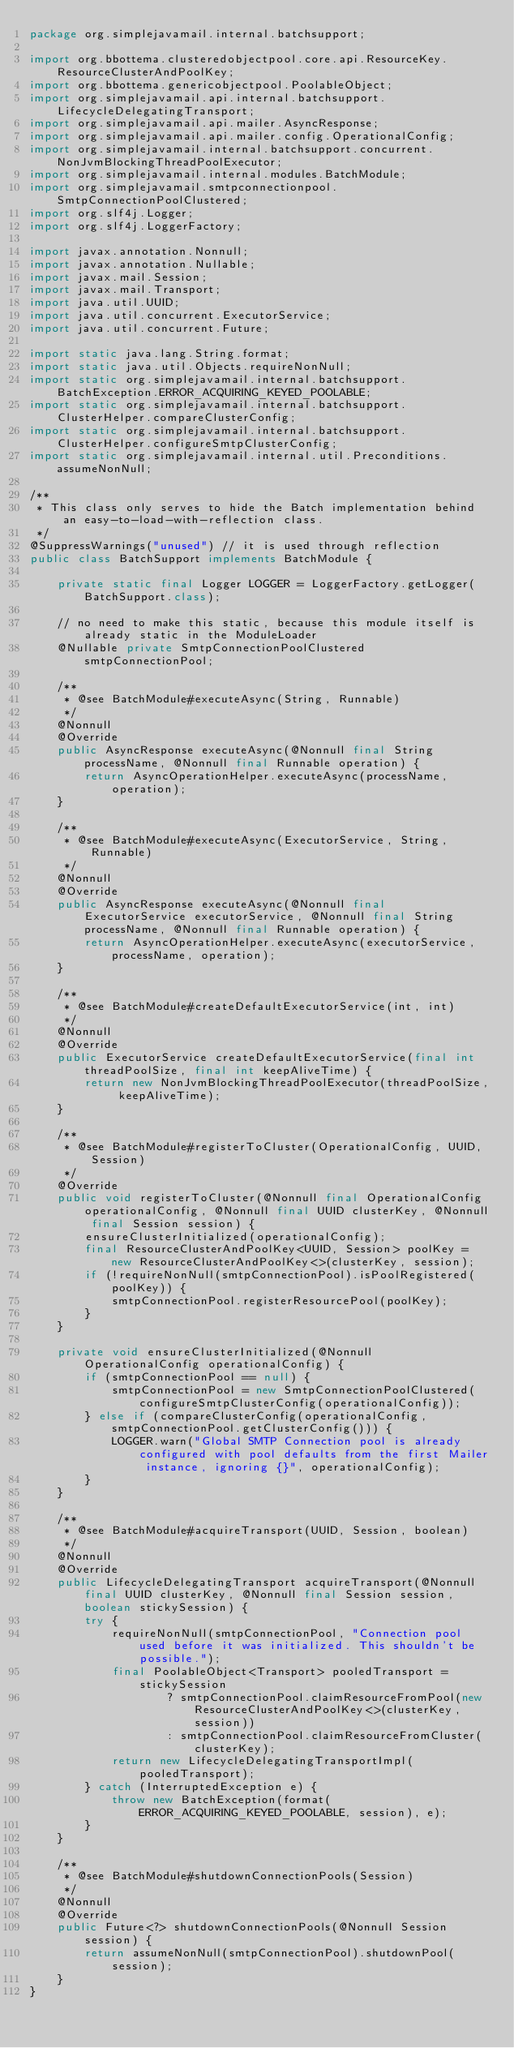<code> <loc_0><loc_0><loc_500><loc_500><_Java_>package org.simplejavamail.internal.batchsupport;

import org.bbottema.clusteredobjectpool.core.api.ResourceKey.ResourceClusterAndPoolKey;
import org.bbottema.genericobjectpool.PoolableObject;
import org.simplejavamail.api.internal.batchsupport.LifecycleDelegatingTransport;
import org.simplejavamail.api.mailer.AsyncResponse;
import org.simplejavamail.api.mailer.config.OperationalConfig;
import org.simplejavamail.internal.batchsupport.concurrent.NonJvmBlockingThreadPoolExecutor;
import org.simplejavamail.internal.modules.BatchModule;
import org.simplejavamail.smtpconnectionpool.SmtpConnectionPoolClustered;
import org.slf4j.Logger;
import org.slf4j.LoggerFactory;

import javax.annotation.Nonnull;
import javax.annotation.Nullable;
import javax.mail.Session;
import javax.mail.Transport;
import java.util.UUID;
import java.util.concurrent.ExecutorService;
import java.util.concurrent.Future;

import static java.lang.String.format;
import static java.util.Objects.requireNonNull;
import static org.simplejavamail.internal.batchsupport.BatchException.ERROR_ACQUIRING_KEYED_POOLABLE;
import static org.simplejavamail.internal.batchsupport.ClusterHelper.compareClusterConfig;
import static org.simplejavamail.internal.batchsupport.ClusterHelper.configureSmtpClusterConfig;
import static org.simplejavamail.internal.util.Preconditions.assumeNonNull;

/**
 * This class only serves to hide the Batch implementation behind an easy-to-load-with-reflection class.
 */
@SuppressWarnings("unused") // it is used through reflection
public class BatchSupport implements BatchModule {

	private static final Logger LOGGER = LoggerFactory.getLogger(BatchSupport.class);

	// no need to make this static, because this module itself is already static in the ModuleLoader
	@Nullable private SmtpConnectionPoolClustered smtpConnectionPool;

	/**
	 * @see BatchModule#executeAsync(String, Runnable)
	 */
	@Nonnull
	@Override
	public AsyncResponse executeAsync(@Nonnull final String processName, @Nonnull final Runnable operation) {
		return AsyncOperationHelper.executeAsync(processName, operation);
	}

	/**
	 * @see BatchModule#executeAsync(ExecutorService, String, Runnable)
	 */
	@Nonnull
	@Override
	public AsyncResponse executeAsync(@Nonnull final ExecutorService executorService, @Nonnull final String processName, @Nonnull final Runnable operation) {
		return AsyncOperationHelper.executeAsync(executorService, processName, operation);
	}

	/**
	 * @see BatchModule#createDefaultExecutorService(int, int)
	 */
	@Nonnull
	@Override
	public ExecutorService createDefaultExecutorService(final int threadPoolSize, final int keepAliveTime) {
		return new NonJvmBlockingThreadPoolExecutor(threadPoolSize, keepAliveTime);
	}

	/**
	 * @see BatchModule#registerToCluster(OperationalConfig, UUID, Session)
	 */
	@Override
	public void registerToCluster(@Nonnull final OperationalConfig operationalConfig, @Nonnull final UUID clusterKey, @Nonnull final Session session) {
		ensureClusterInitialized(operationalConfig);
		final ResourceClusterAndPoolKey<UUID, Session> poolKey = new ResourceClusterAndPoolKey<>(clusterKey, session);
		if (!requireNonNull(smtpConnectionPool).isPoolRegistered(poolKey)) {
			smtpConnectionPool.registerResourcePool(poolKey);
		}
	}

	private void ensureClusterInitialized(@Nonnull OperationalConfig operationalConfig) {
		if (smtpConnectionPool == null) {
			smtpConnectionPool = new SmtpConnectionPoolClustered(configureSmtpClusterConfig(operationalConfig));
		} else if (compareClusterConfig(operationalConfig, smtpConnectionPool.getClusterConfig())) {
			LOGGER.warn("Global SMTP Connection pool is already configured with pool defaults from the first Mailer instance, ignoring {}", operationalConfig);
		}
	}

	/**
	 * @see BatchModule#acquireTransport(UUID, Session, boolean)
	 */
	@Nonnull
	@Override
	public LifecycleDelegatingTransport acquireTransport(@Nonnull final UUID clusterKey, @Nonnull final Session session, boolean stickySession) {
		try {
			requireNonNull(smtpConnectionPool, "Connection pool used before it was initialized. This shouldn't be possible.");
			final PoolableObject<Transport> pooledTransport = stickySession
					? smtpConnectionPool.claimResourceFromPool(new ResourceClusterAndPoolKey<>(clusterKey, session))
					: smtpConnectionPool.claimResourceFromCluster(clusterKey);
			return new LifecycleDelegatingTransportImpl(pooledTransport);
		} catch (InterruptedException e) {
			throw new BatchException(format(ERROR_ACQUIRING_KEYED_POOLABLE, session), e);
		}
	}

	/**
	 * @see BatchModule#shutdownConnectionPools(Session)
	 */
	@Nonnull
	@Override
	public Future<?> shutdownConnectionPools(@Nonnull Session session) {
		return assumeNonNull(smtpConnectionPool).shutdownPool(session);
	}
}</code> 